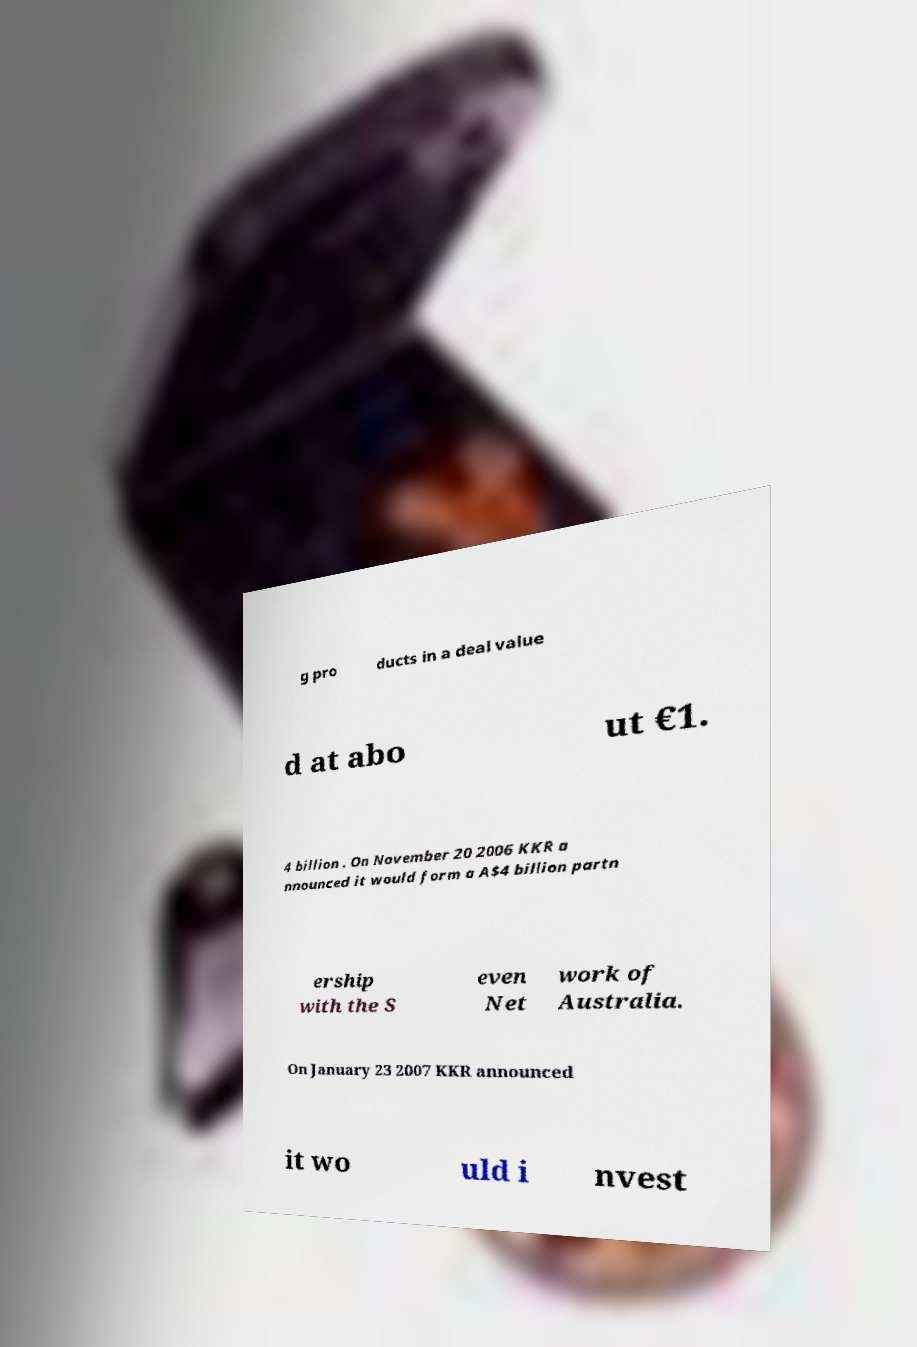Could you extract and type out the text from this image? g pro ducts in a deal value d at abo ut €1. 4 billion . On November 20 2006 KKR a nnounced it would form a A$4 billion partn ership with the S even Net work of Australia. On January 23 2007 KKR announced it wo uld i nvest 